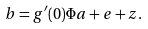Convert formula to latex. <formula><loc_0><loc_0><loc_500><loc_500>b = g ^ { \prime } ( 0 ) \Phi a + e + z .</formula> 